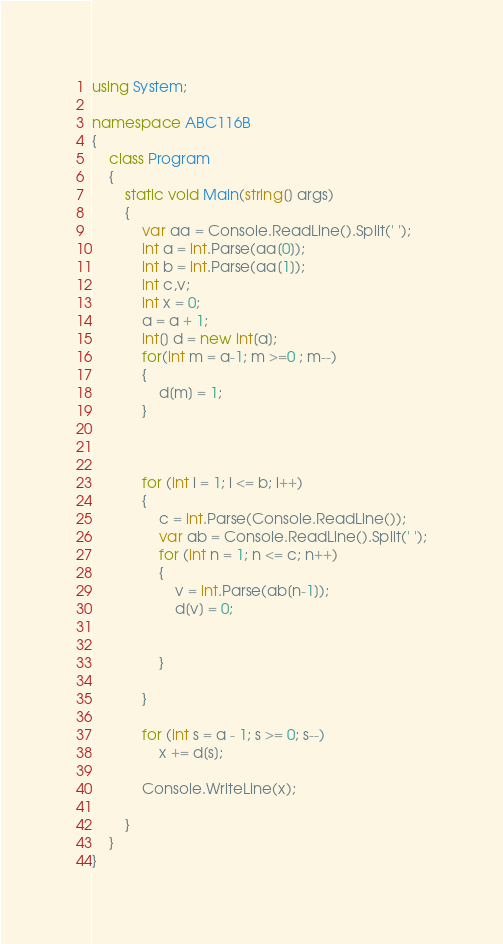<code> <loc_0><loc_0><loc_500><loc_500><_C#_>using System;

namespace ABC116B
{
    class Program
    {
        static void Main(string[] args)
        {
            var aa = Console.ReadLine().Split(' ');
            int a = int.Parse(aa[0]);
            int b = int.Parse(aa[1]);
            int c,v;
            int x = 0;
            a = a + 1;
            int[] d = new int[a];
            for(int m = a-1; m >=0 ; m--)
            {
                d[m] = 1;
            }



            for (int i = 1; i <= b; i++)
            {
                c = int.Parse(Console.ReadLine());
                var ab = Console.ReadLine().Split(' ');
                for (int n = 1; n <= c; n++)
                {
                    v = int.Parse(ab[n-1]);
                    d[v] = 0;


                }

            }

            for (int s = a - 1; s >= 0; s--)
                x += d[s];

            Console.WriteLine(x);

        }
    }
}</code> 